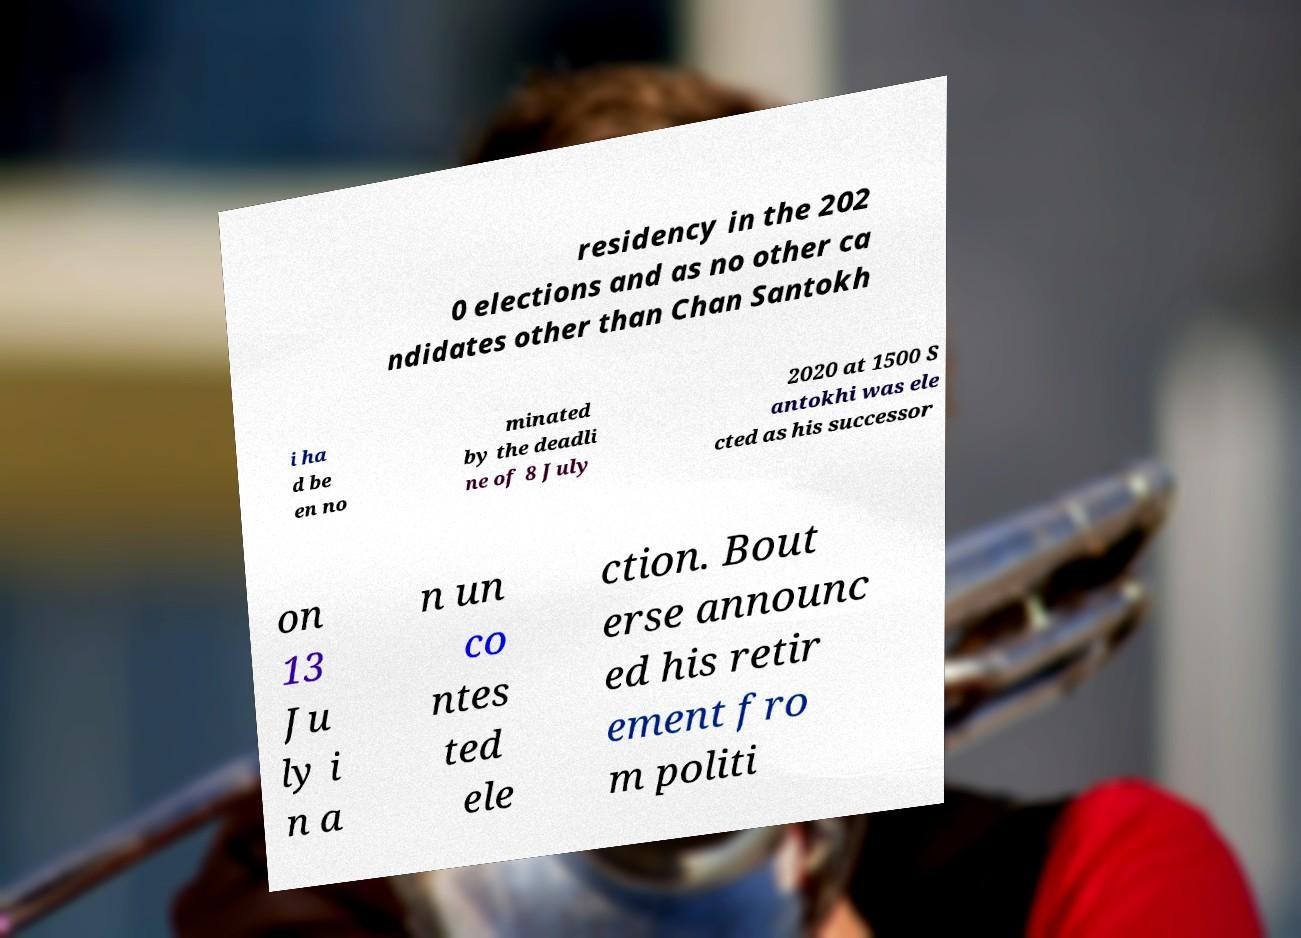Please identify and transcribe the text found in this image. residency in the 202 0 elections and as no other ca ndidates other than Chan Santokh i ha d be en no minated by the deadli ne of 8 July 2020 at 1500 S antokhi was ele cted as his successor on 13 Ju ly i n a n un co ntes ted ele ction. Bout erse announc ed his retir ement fro m politi 